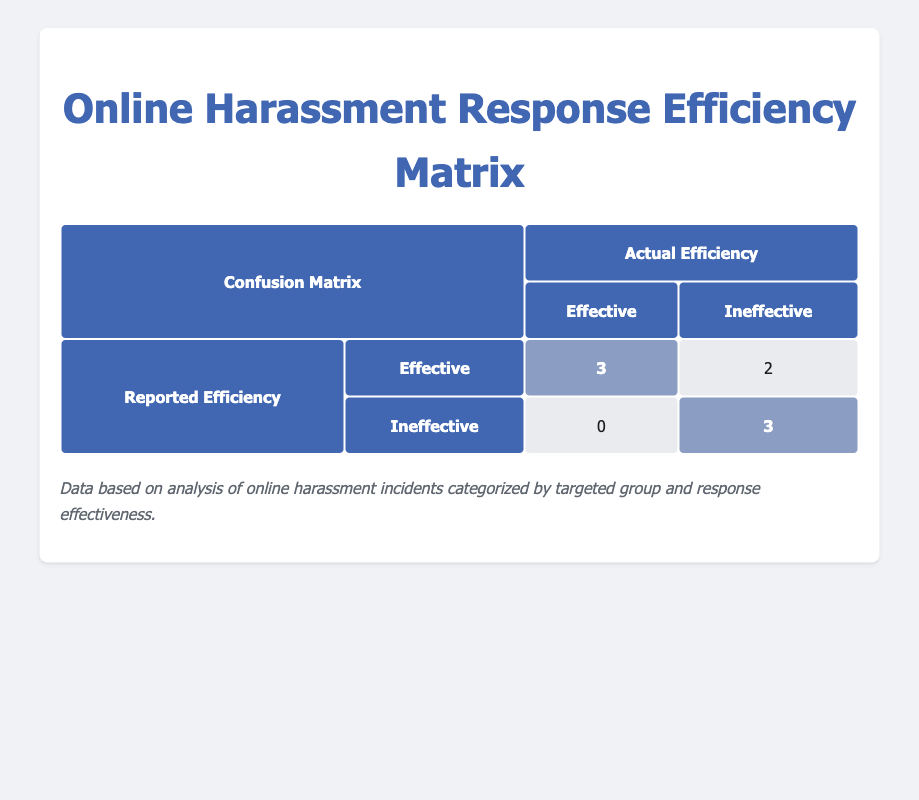What is the total number of incidents reported as effective? From the table, we identify that the 'Effective' incidents include 3 from the 'Reported Efficiency' marked as 'Effective' and 0 from 'Ineffective', resulting in a total of 3 effective incidents.
Answer: 3 How many incidents had an actual efficiency that was ineffective? According to the matrix, the incidents that were reported as effective but were actually ineffective amount to 2. Additionally, the ineffective report in the ineffective category also gives us 3, resulting in a total of 5 incidents reported as ineffective.
Answer: 5 What percentage of the 'Reported Efficiency' labeled 'Effective' was actually effective? There are 3 incidents reported as effective and all of them are effectively handled. To find the percentage, (3/3)*100 equals 100%. Thus, 100% of reported effective incidents were actually effective.
Answer: 100% Is it true that all incidents reported as ineffective also had an actual efficiency that was ineffective? By examining the table, the two groups reported as ineffective that report 'Ineffective' also confirmed as ineffective. However, there are incidents marked as effective in reported efficiency that returned as ineffective in actual efficiency; so the statement is false.
Answer: No What is the ratio of incidents reported as effective to those reported as ineffective? In the matrix, there are 3 reported as effective and 3 reported as ineffective. Thus, the ratio is 3:3, which simplifies to 1:1.
Answer: 1:1 How many incidents were related to harassment against women? Looking through the table, we see three incidents targeting women, namely 'Sexist Comments', 'Doxxing', and 'Threats of Violence'.
Answer: 3 What is the total number of incidents recorded in the study? The table lists a total of 8 harassment incidents categorized by targeted group and type, thus the total number of incidents is 8.
Answer: 8 Which targeted group experienced the highest actual efficiency? From the matrix, both Muslims and People with Disabilities had incidents reported as effective with actual efficiency reflected as effective; therefore, both groups experienced the highest actual efficiency.
Answer: Muslims and People with Disabilities 